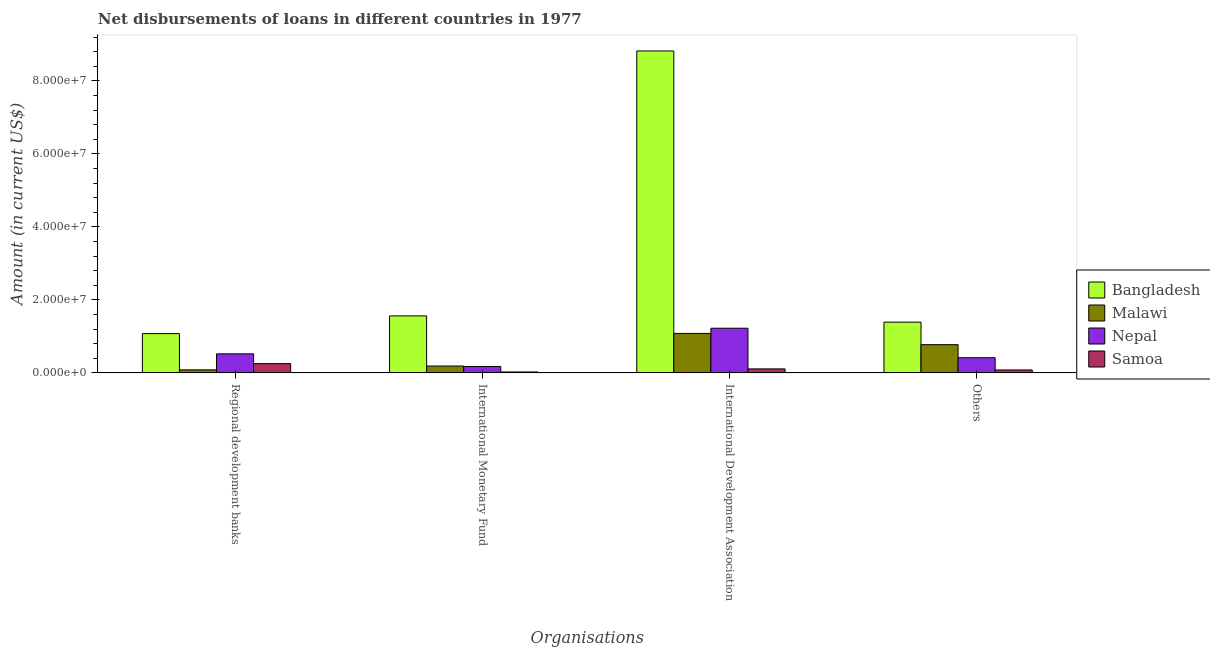How many different coloured bars are there?
Provide a short and direct response. 4. How many groups of bars are there?
Provide a short and direct response. 4. How many bars are there on the 2nd tick from the left?
Offer a terse response. 4. How many bars are there on the 1st tick from the right?
Your answer should be very brief. 4. What is the label of the 4th group of bars from the left?
Offer a terse response. Others. What is the amount of loan disimbursed by other organisations in Nepal?
Keep it short and to the point. 4.15e+06. Across all countries, what is the maximum amount of loan disimbursed by international monetary fund?
Offer a terse response. 1.56e+07. Across all countries, what is the minimum amount of loan disimbursed by other organisations?
Give a very brief answer. 8.00e+05. In which country was the amount of loan disimbursed by international development association maximum?
Provide a short and direct response. Bangladesh. In which country was the amount of loan disimbursed by international monetary fund minimum?
Your response must be concise. Samoa. What is the total amount of loan disimbursed by other organisations in the graph?
Provide a succinct answer. 2.66e+07. What is the difference between the amount of loan disimbursed by international development association in Bangladesh and that in Nepal?
Your response must be concise. 7.60e+07. What is the difference between the amount of loan disimbursed by other organisations in Nepal and the amount of loan disimbursed by regional development banks in Bangladesh?
Make the answer very short. -6.60e+06. What is the average amount of loan disimbursed by regional development banks per country?
Keep it short and to the point. 4.83e+06. What is the difference between the amount of loan disimbursed by international development association and amount of loan disimbursed by regional development banks in Nepal?
Your answer should be compact. 7.02e+06. In how many countries, is the amount of loan disimbursed by international development association greater than 24000000 US$?
Keep it short and to the point. 1. What is the ratio of the amount of loan disimbursed by other organisations in Samoa to that in Nepal?
Your answer should be compact. 0.19. Is the amount of loan disimbursed by international development association in Bangladesh less than that in Samoa?
Ensure brevity in your answer.  No. Is the difference between the amount of loan disimbursed by international development association in Nepal and Samoa greater than the difference between the amount of loan disimbursed by regional development banks in Nepal and Samoa?
Keep it short and to the point. Yes. What is the difference between the highest and the second highest amount of loan disimbursed by regional development banks?
Give a very brief answer. 5.54e+06. What is the difference between the highest and the lowest amount of loan disimbursed by regional development banks?
Give a very brief answer. 9.93e+06. What does the 2nd bar from the left in International Monetary Fund represents?
Offer a terse response. Malawi. What does the 2nd bar from the right in International Development Association represents?
Offer a very short reply. Nepal. How many countries are there in the graph?
Offer a terse response. 4. Are the values on the major ticks of Y-axis written in scientific E-notation?
Your response must be concise. Yes. How are the legend labels stacked?
Offer a terse response. Vertical. What is the title of the graph?
Provide a succinct answer. Net disbursements of loans in different countries in 1977. Does "Suriname" appear as one of the legend labels in the graph?
Provide a short and direct response. No. What is the label or title of the X-axis?
Provide a succinct answer. Organisations. What is the label or title of the Y-axis?
Your answer should be very brief. Amount (in current US$). What is the Amount (in current US$) in Bangladesh in Regional development banks?
Give a very brief answer. 1.08e+07. What is the Amount (in current US$) in Malawi in Regional development banks?
Your response must be concise. 8.28e+05. What is the Amount (in current US$) in Nepal in Regional development banks?
Your answer should be compact. 5.21e+06. What is the Amount (in current US$) of Samoa in Regional development banks?
Provide a short and direct response. 2.54e+06. What is the Amount (in current US$) of Bangladesh in International Monetary Fund?
Offer a terse response. 1.56e+07. What is the Amount (in current US$) in Malawi in International Monetary Fund?
Your answer should be very brief. 1.87e+06. What is the Amount (in current US$) in Nepal in International Monetary Fund?
Keep it short and to the point. 1.75e+06. What is the Amount (in current US$) of Samoa in International Monetary Fund?
Your answer should be very brief. 2.50e+05. What is the Amount (in current US$) in Bangladesh in International Development Association?
Make the answer very short. 8.82e+07. What is the Amount (in current US$) of Malawi in International Development Association?
Offer a terse response. 1.08e+07. What is the Amount (in current US$) in Nepal in International Development Association?
Your answer should be very brief. 1.22e+07. What is the Amount (in current US$) of Samoa in International Development Association?
Ensure brevity in your answer.  1.09e+06. What is the Amount (in current US$) in Bangladesh in Others?
Offer a very short reply. 1.39e+07. What is the Amount (in current US$) in Malawi in Others?
Your answer should be compact. 7.72e+06. What is the Amount (in current US$) of Nepal in Others?
Ensure brevity in your answer.  4.15e+06. Across all Organisations, what is the maximum Amount (in current US$) in Bangladesh?
Your response must be concise. 8.82e+07. Across all Organisations, what is the maximum Amount (in current US$) in Malawi?
Your answer should be very brief. 1.08e+07. Across all Organisations, what is the maximum Amount (in current US$) of Nepal?
Make the answer very short. 1.22e+07. Across all Organisations, what is the maximum Amount (in current US$) of Samoa?
Your answer should be very brief. 2.54e+06. Across all Organisations, what is the minimum Amount (in current US$) of Bangladesh?
Give a very brief answer. 1.08e+07. Across all Organisations, what is the minimum Amount (in current US$) in Malawi?
Make the answer very short. 8.28e+05. Across all Organisations, what is the minimum Amount (in current US$) of Nepal?
Your response must be concise. 1.75e+06. Across all Organisations, what is the minimum Amount (in current US$) in Samoa?
Give a very brief answer. 2.50e+05. What is the total Amount (in current US$) of Bangladesh in the graph?
Your response must be concise. 1.28e+08. What is the total Amount (in current US$) in Malawi in the graph?
Offer a very short reply. 2.12e+07. What is the total Amount (in current US$) of Nepal in the graph?
Your response must be concise. 2.33e+07. What is the total Amount (in current US$) of Samoa in the graph?
Give a very brief answer. 4.67e+06. What is the difference between the Amount (in current US$) in Bangladesh in Regional development banks and that in International Monetary Fund?
Make the answer very short. -4.86e+06. What is the difference between the Amount (in current US$) in Malawi in Regional development banks and that in International Monetary Fund?
Give a very brief answer. -1.05e+06. What is the difference between the Amount (in current US$) of Nepal in Regional development banks and that in International Monetary Fund?
Offer a terse response. 3.46e+06. What is the difference between the Amount (in current US$) of Samoa in Regional development banks and that in International Monetary Fund?
Offer a very short reply. 2.28e+06. What is the difference between the Amount (in current US$) in Bangladesh in Regional development banks and that in International Development Association?
Offer a very short reply. -7.75e+07. What is the difference between the Amount (in current US$) in Malawi in Regional development banks and that in International Development Association?
Provide a short and direct response. -9.99e+06. What is the difference between the Amount (in current US$) in Nepal in Regional development banks and that in International Development Association?
Keep it short and to the point. -7.02e+06. What is the difference between the Amount (in current US$) in Samoa in Regional development banks and that in International Development Association?
Make the answer very short. 1.45e+06. What is the difference between the Amount (in current US$) of Bangladesh in Regional development banks and that in Others?
Provide a succinct answer. -3.14e+06. What is the difference between the Amount (in current US$) in Malawi in Regional development banks and that in Others?
Your answer should be compact. -6.89e+06. What is the difference between the Amount (in current US$) of Nepal in Regional development banks and that in Others?
Your response must be concise. 1.06e+06. What is the difference between the Amount (in current US$) of Samoa in Regional development banks and that in Others?
Your answer should be very brief. 1.74e+06. What is the difference between the Amount (in current US$) in Bangladesh in International Monetary Fund and that in International Development Association?
Provide a short and direct response. -7.26e+07. What is the difference between the Amount (in current US$) of Malawi in International Monetary Fund and that in International Development Association?
Make the answer very short. -8.94e+06. What is the difference between the Amount (in current US$) of Nepal in International Monetary Fund and that in International Development Association?
Give a very brief answer. -1.05e+07. What is the difference between the Amount (in current US$) in Samoa in International Monetary Fund and that in International Development Association?
Your answer should be compact. -8.36e+05. What is the difference between the Amount (in current US$) in Bangladesh in International Monetary Fund and that in Others?
Provide a short and direct response. 1.72e+06. What is the difference between the Amount (in current US$) of Malawi in International Monetary Fund and that in Others?
Keep it short and to the point. -5.85e+06. What is the difference between the Amount (in current US$) in Nepal in International Monetary Fund and that in Others?
Offer a very short reply. -2.40e+06. What is the difference between the Amount (in current US$) in Samoa in International Monetary Fund and that in Others?
Offer a very short reply. -5.50e+05. What is the difference between the Amount (in current US$) of Bangladesh in International Development Association and that in Others?
Make the answer very short. 7.43e+07. What is the difference between the Amount (in current US$) of Malawi in International Development Association and that in Others?
Ensure brevity in your answer.  3.09e+06. What is the difference between the Amount (in current US$) of Nepal in International Development Association and that in Others?
Offer a very short reply. 8.08e+06. What is the difference between the Amount (in current US$) in Samoa in International Development Association and that in Others?
Your answer should be compact. 2.86e+05. What is the difference between the Amount (in current US$) in Bangladesh in Regional development banks and the Amount (in current US$) in Malawi in International Monetary Fund?
Keep it short and to the point. 8.88e+06. What is the difference between the Amount (in current US$) of Bangladesh in Regional development banks and the Amount (in current US$) of Nepal in International Monetary Fund?
Give a very brief answer. 9.01e+06. What is the difference between the Amount (in current US$) in Bangladesh in Regional development banks and the Amount (in current US$) in Samoa in International Monetary Fund?
Ensure brevity in your answer.  1.05e+07. What is the difference between the Amount (in current US$) of Malawi in Regional development banks and the Amount (in current US$) of Nepal in International Monetary Fund?
Your answer should be very brief. -9.21e+05. What is the difference between the Amount (in current US$) in Malawi in Regional development banks and the Amount (in current US$) in Samoa in International Monetary Fund?
Keep it short and to the point. 5.78e+05. What is the difference between the Amount (in current US$) in Nepal in Regional development banks and the Amount (in current US$) in Samoa in International Monetary Fund?
Make the answer very short. 4.96e+06. What is the difference between the Amount (in current US$) of Bangladesh in Regional development banks and the Amount (in current US$) of Malawi in International Development Association?
Offer a very short reply. -6.10e+04. What is the difference between the Amount (in current US$) in Bangladesh in Regional development banks and the Amount (in current US$) in Nepal in International Development Association?
Your answer should be compact. -1.48e+06. What is the difference between the Amount (in current US$) of Bangladesh in Regional development banks and the Amount (in current US$) of Samoa in International Development Association?
Ensure brevity in your answer.  9.67e+06. What is the difference between the Amount (in current US$) in Malawi in Regional development banks and the Amount (in current US$) in Nepal in International Development Association?
Your response must be concise. -1.14e+07. What is the difference between the Amount (in current US$) in Malawi in Regional development banks and the Amount (in current US$) in Samoa in International Development Association?
Your answer should be very brief. -2.58e+05. What is the difference between the Amount (in current US$) of Nepal in Regional development banks and the Amount (in current US$) of Samoa in International Development Association?
Ensure brevity in your answer.  4.13e+06. What is the difference between the Amount (in current US$) of Bangladesh in Regional development banks and the Amount (in current US$) of Malawi in Others?
Your response must be concise. 3.03e+06. What is the difference between the Amount (in current US$) of Bangladesh in Regional development banks and the Amount (in current US$) of Nepal in Others?
Offer a terse response. 6.60e+06. What is the difference between the Amount (in current US$) of Bangladesh in Regional development banks and the Amount (in current US$) of Samoa in Others?
Offer a very short reply. 9.96e+06. What is the difference between the Amount (in current US$) of Malawi in Regional development banks and the Amount (in current US$) of Nepal in Others?
Your answer should be very brief. -3.32e+06. What is the difference between the Amount (in current US$) of Malawi in Regional development banks and the Amount (in current US$) of Samoa in Others?
Your answer should be compact. 2.80e+04. What is the difference between the Amount (in current US$) in Nepal in Regional development banks and the Amount (in current US$) in Samoa in Others?
Your response must be concise. 4.41e+06. What is the difference between the Amount (in current US$) of Bangladesh in International Monetary Fund and the Amount (in current US$) of Malawi in International Development Association?
Offer a very short reply. 4.80e+06. What is the difference between the Amount (in current US$) of Bangladesh in International Monetary Fund and the Amount (in current US$) of Nepal in International Development Association?
Offer a very short reply. 3.38e+06. What is the difference between the Amount (in current US$) in Bangladesh in International Monetary Fund and the Amount (in current US$) in Samoa in International Development Association?
Offer a terse response. 1.45e+07. What is the difference between the Amount (in current US$) in Malawi in International Monetary Fund and the Amount (in current US$) in Nepal in International Development Association?
Your response must be concise. -1.04e+07. What is the difference between the Amount (in current US$) of Malawi in International Monetary Fund and the Amount (in current US$) of Samoa in International Development Association?
Your response must be concise. 7.88e+05. What is the difference between the Amount (in current US$) in Nepal in International Monetary Fund and the Amount (in current US$) in Samoa in International Development Association?
Offer a terse response. 6.63e+05. What is the difference between the Amount (in current US$) in Bangladesh in International Monetary Fund and the Amount (in current US$) in Malawi in Others?
Provide a succinct answer. 7.89e+06. What is the difference between the Amount (in current US$) of Bangladesh in International Monetary Fund and the Amount (in current US$) of Nepal in Others?
Make the answer very short. 1.15e+07. What is the difference between the Amount (in current US$) of Bangladesh in International Monetary Fund and the Amount (in current US$) of Samoa in Others?
Your answer should be compact. 1.48e+07. What is the difference between the Amount (in current US$) of Malawi in International Monetary Fund and the Amount (in current US$) of Nepal in Others?
Keep it short and to the point. -2.28e+06. What is the difference between the Amount (in current US$) of Malawi in International Monetary Fund and the Amount (in current US$) of Samoa in Others?
Your answer should be compact. 1.07e+06. What is the difference between the Amount (in current US$) of Nepal in International Monetary Fund and the Amount (in current US$) of Samoa in Others?
Your answer should be compact. 9.49e+05. What is the difference between the Amount (in current US$) of Bangladesh in International Development Association and the Amount (in current US$) of Malawi in Others?
Keep it short and to the point. 8.05e+07. What is the difference between the Amount (in current US$) of Bangladesh in International Development Association and the Amount (in current US$) of Nepal in Others?
Give a very brief answer. 8.41e+07. What is the difference between the Amount (in current US$) of Bangladesh in International Development Association and the Amount (in current US$) of Samoa in Others?
Make the answer very short. 8.74e+07. What is the difference between the Amount (in current US$) in Malawi in International Development Association and the Amount (in current US$) in Nepal in Others?
Ensure brevity in your answer.  6.67e+06. What is the difference between the Amount (in current US$) in Malawi in International Development Association and the Amount (in current US$) in Samoa in Others?
Your answer should be compact. 1.00e+07. What is the difference between the Amount (in current US$) in Nepal in International Development Association and the Amount (in current US$) in Samoa in Others?
Your answer should be compact. 1.14e+07. What is the average Amount (in current US$) in Bangladesh per Organisations?
Keep it short and to the point. 3.21e+07. What is the average Amount (in current US$) of Malawi per Organisations?
Ensure brevity in your answer.  5.31e+06. What is the average Amount (in current US$) in Nepal per Organisations?
Ensure brevity in your answer.  5.84e+06. What is the average Amount (in current US$) of Samoa per Organisations?
Offer a very short reply. 1.17e+06. What is the difference between the Amount (in current US$) of Bangladesh and Amount (in current US$) of Malawi in Regional development banks?
Your answer should be compact. 9.93e+06. What is the difference between the Amount (in current US$) in Bangladesh and Amount (in current US$) in Nepal in Regional development banks?
Offer a terse response. 5.54e+06. What is the difference between the Amount (in current US$) of Bangladesh and Amount (in current US$) of Samoa in Regional development banks?
Make the answer very short. 8.22e+06. What is the difference between the Amount (in current US$) of Malawi and Amount (in current US$) of Nepal in Regional development banks?
Give a very brief answer. -4.38e+06. What is the difference between the Amount (in current US$) of Malawi and Amount (in current US$) of Samoa in Regional development banks?
Provide a succinct answer. -1.71e+06. What is the difference between the Amount (in current US$) of Nepal and Amount (in current US$) of Samoa in Regional development banks?
Offer a very short reply. 2.68e+06. What is the difference between the Amount (in current US$) in Bangladesh and Amount (in current US$) in Malawi in International Monetary Fund?
Offer a very short reply. 1.37e+07. What is the difference between the Amount (in current US$) of Bangladesh and Amount (in current US$) of Nepal in International Monetary Fund?
Give a very brief answer. 1.39e+07. What is the difference between the Amount (in current US$) in Bangladesh and Amount (in current US$) in Samoa in International Monetary Fund?
Your response must be concise. 1.54e+07. What is the difference between the Amount (in current US$) of Malawi and Amount (in current US$) of Nepal in International Monetary Fund?
Keep it short and to the point. 1.25e+05. What is the difference between the Amount (in current US$) in Malawi and Amount (in current US$) in Samoa in International Monetary Fund?
Ensure brevity in your answer.  1.62e+06. What is the difference between the Amount (in current US$) of Nepal and Amount (in current US$) of Samoa in International Monetary Fund?
Your response must be concise. 1.50e+06. What is the difference between the Amount (in current US$) of Bangladesh and Amount (in current US$) of Malawi in International Development Association?
Offer a terse response. 7.74e+07. What is the difference between the Amount (in current US$) of Bangladesh and Amount (in current US$) of Nepal in International Development Association?
Offer a very short reply. 7.60e+07. What is the difference between the Amount (in current US$) of Bangladesh and Amount (in current US$) of Samoa in International Development Association?
Offer a very short reply. 8.71e+07. What is the difference between the Amount (in current US$) in Malawi and Amount (in current US$) in Nepal in International Development Association?
Your answer should be compact. -1.42e+06. What is the difference between the Amount (in current US$) in Malawi and Amount (in current US$) in Samoa in International Development Association?
Give a very brief answer. 9.73e+06. What is the difference between the Amount (in current US$) of Nepal and Amount (in current US$) of Samoa in International Development Association?
Offer a terse response. 1.11e+07. What is the difference between the Amount (in current US$) of Bangladesh and Amount (in current US$) of Malawi in Others?
Make the answer very short. 6.18e+06. What is the difference between the Amount (in current US$) in Bangladesh and Amount (in current US$) in Nepal in Others?
Your response must be concise. 9.75e+06. What is the difference between the Amount (in current US$) in Bangladesh and Amount (in current US$) in Samoa in Others?
Make the answer very short. 1.31e+07. What is the difference between the Amount (in current US$) in Malawi and Amount (in current US$) in Nepal in Others?
Give a very brief answer. 3.57e+06. What is the difference between the Amount (in current US$) in Malawi and Amount (in current US$) in Samoa in Others?
Provide a succinct answer. 6.92e+06. What is the difference between the Amount (in current US$) in Nepal and Amount (in current US$) in Samoa in Others?
Make the answer very short. 3.35e+06. What is the ratio of the Amount (in current US$) in Bangladesh in Regional development banks to that in International Monetary Fund?
Keep it short and to the point. 0.69. What is the ratio of the Amount (in current US$) of Malawi in Regional development banks to that in International Monetary Fund?
Offer a terse response. 0.44. What is the ratio of the Amount (in current US$) in Nepal in Regional development banks to that in International Monetary Fund?
Your answer should be compact. 2.98. What is the ratio of the Amount (in current US$) of Samoa in Regional development banks to that in International Monetary Fund?
Keep it short and to the point. 10.14. What is the ratio of the Amount (in current US$) in Bangladesh in Regional development banks to that in International Development Association?
Your answer should be compact. 0.12. What is the ratio of the Amount (in current US$) of Malawi in Regional development banks to that in International Development Association?
Offer a very short reply. 0.08. What is the ratio of the Amount (in current US$) of Nepal in Regional development banks to that in International Development Association?
Make the answer very short. 0.43. What is the ratio of the Amount (in current US$) of Samoa in Regional development banks to that in International Development Association?
Offer a terse response. 2.33. What is the ratio of the Amount (in current US$) of Bangladesh in Regional development banks to that in Others?
Offer a very short reply. 0.77. What is the ratio of the Amount (in current US$) of Malawi in Regional development banks to that in Others?
Offer a very short reply. 0.11. What is the ratio of the Amount (in current US$) in Nepal in Regional development banks to that in Others?
Provide a succinct answer. 1.26. What is the ratio of the Amount (in current US$) in Samoa in Regional development banks to that in Others?
Your response must be concise. 3.17. What is the ratio of the Amount (in current US$) of Bangladesh in International Monetary Fund to that in International Development Association?
Your response must be concise. 0.18. What is the ratio of the Amount (in current US$) in Malawi in International Monetary Fund to that in International Development Association?
Keep it short and to the point. 0.17. What is the ratio of the Amount (in current US$) of Nepal in International Monetary Fund to that in International Development Association?
Keep it short and to the point. 0.14. What is the ratio of the Amount (in current US$) of Samoa in International Monetary Fund to that in International Development Association?
Your answer should be very brief. 0.23. What is the ratio of the Amount (in current US$) in Bangladesh in International Monetary Fund to that in Others?
Offer a terse response. 1.12. What is the ratio of the Amount (in current US$) in Malawi in International Monetary Fund to that in Others?
Provide a short and direct response. 0.24. What is the ratio of the Amount (in current US$) in Nepal in International Monetary Fund to that in Others?
Offer a terse response. 0.42. What is the ratio of the Amount (in current US$) of Samoa in International Monetary Fund to that in Others?
Offer a very short reply. 0.31. What is the ratio of the Amount (in current US$) in Bangladesh in International Development Association to that in Others?
Keep it short and to the point. 6.35. What is the ratio of the Amount (in current US$) of Malawi in International Development Association to that in Others?
Provide a succinct answer. 1.4. What is the ratio of the Amount (in current US$) of Nepal in International Development Association to that in Others?
Ensure brevity in your answer.  2.95. What is the ratio of the Amount (in current US$) of Samoa in International Development Association to that in Others?
Keep it short and to the point. 1.36. What is the difference between the highest and the second highest Amount (in current US$) in Bangladesh?
Keep it short and to the point. 7.26e+07. What is the difference between the highest and the second highest Amount (in current US$) in Malawi?
Provide a short and direct response. 3.09e+06. What is the difference between the highest and the second highest Amount (in current US$) of Nepal?
Provide a short and direct response. 7.02e+06. What is the difference between the highest and the second highest Amount (in current US$) in Samoa?
Offer a very short reply. 1.45e+06. What is the difference between the highest and the lowest Amount (in current US$) in Bangladesh?
Make the answer very short. 7.75e+07. What is the difference between the highest and the lowest Amount (in current US$) in Malawi?
Give a very brief answer. 9.99e+06. What is the difference between the highest and the lowest Amount (in current US$) in Nepal?
Make the answer very short. 1.05e+07. What is the difference between the highest and the lowest Amount (in current US$) in Samoa?
Provide a succinct answer. 2.28e+06. 